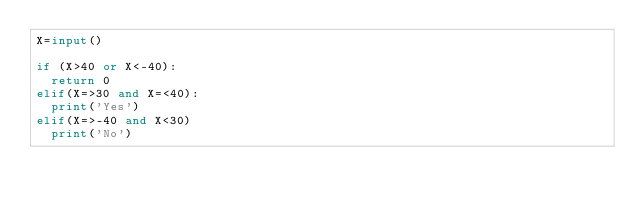Convert code to text. <code><loc_0><loc_0><loc_500><loc_500><_Python_>X=input()

if (X>40 or X<-40):
  return 0
elif(X=>30 and X=<40):
  print('Yes')
elif(X=>-40 and X<30)
  print('No')

</code> 